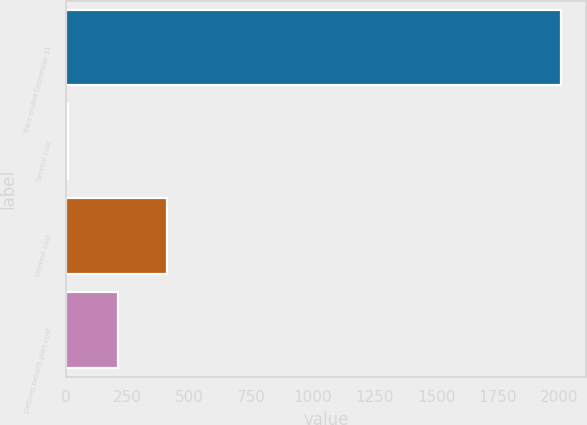Convert chart. <chart><loc_0><loc_0><loc_500><loc_500><bar_chart><fcel>Years ended December 31<fcel>Service cost<fcel>Interest cost<fcel>Defined-benefit plan cost<nl><fcel>2006<fcel>10.3<fcel>409.44<fcel>209.87<nl></chart> 